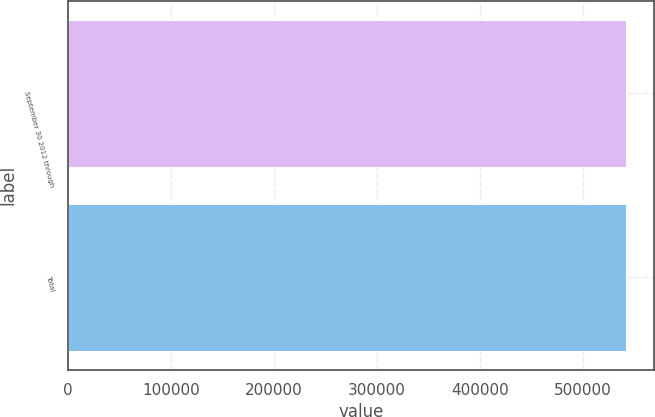<chart> <loc_0><loc_0><loc_500><loc_500><bar_chart><fcel>September 30 2012 through<fcel>Total<nl><fcel>542251<fcel>542251<nl></chart> 